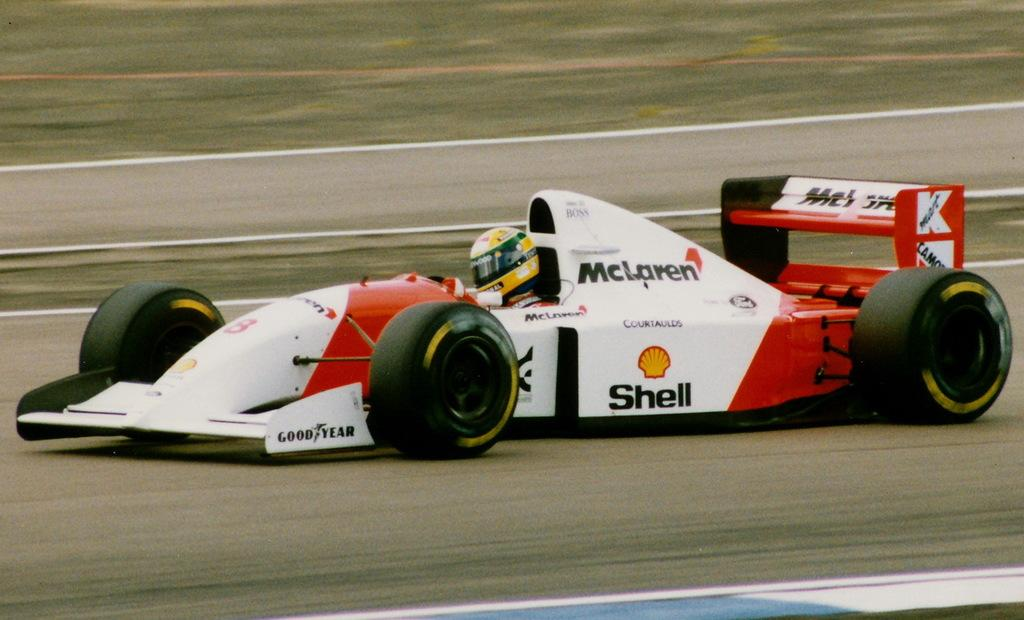<image>
Create a compact narrative representing the image presented. A McLaren raice car moving down a track 